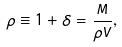Convert formula to latex. <formula><loc_0><loc_0><loc_500><loc_500>\rho \equiv 1 + \delta = \frac { M } { \bar { \rho } V } ,</formula> 